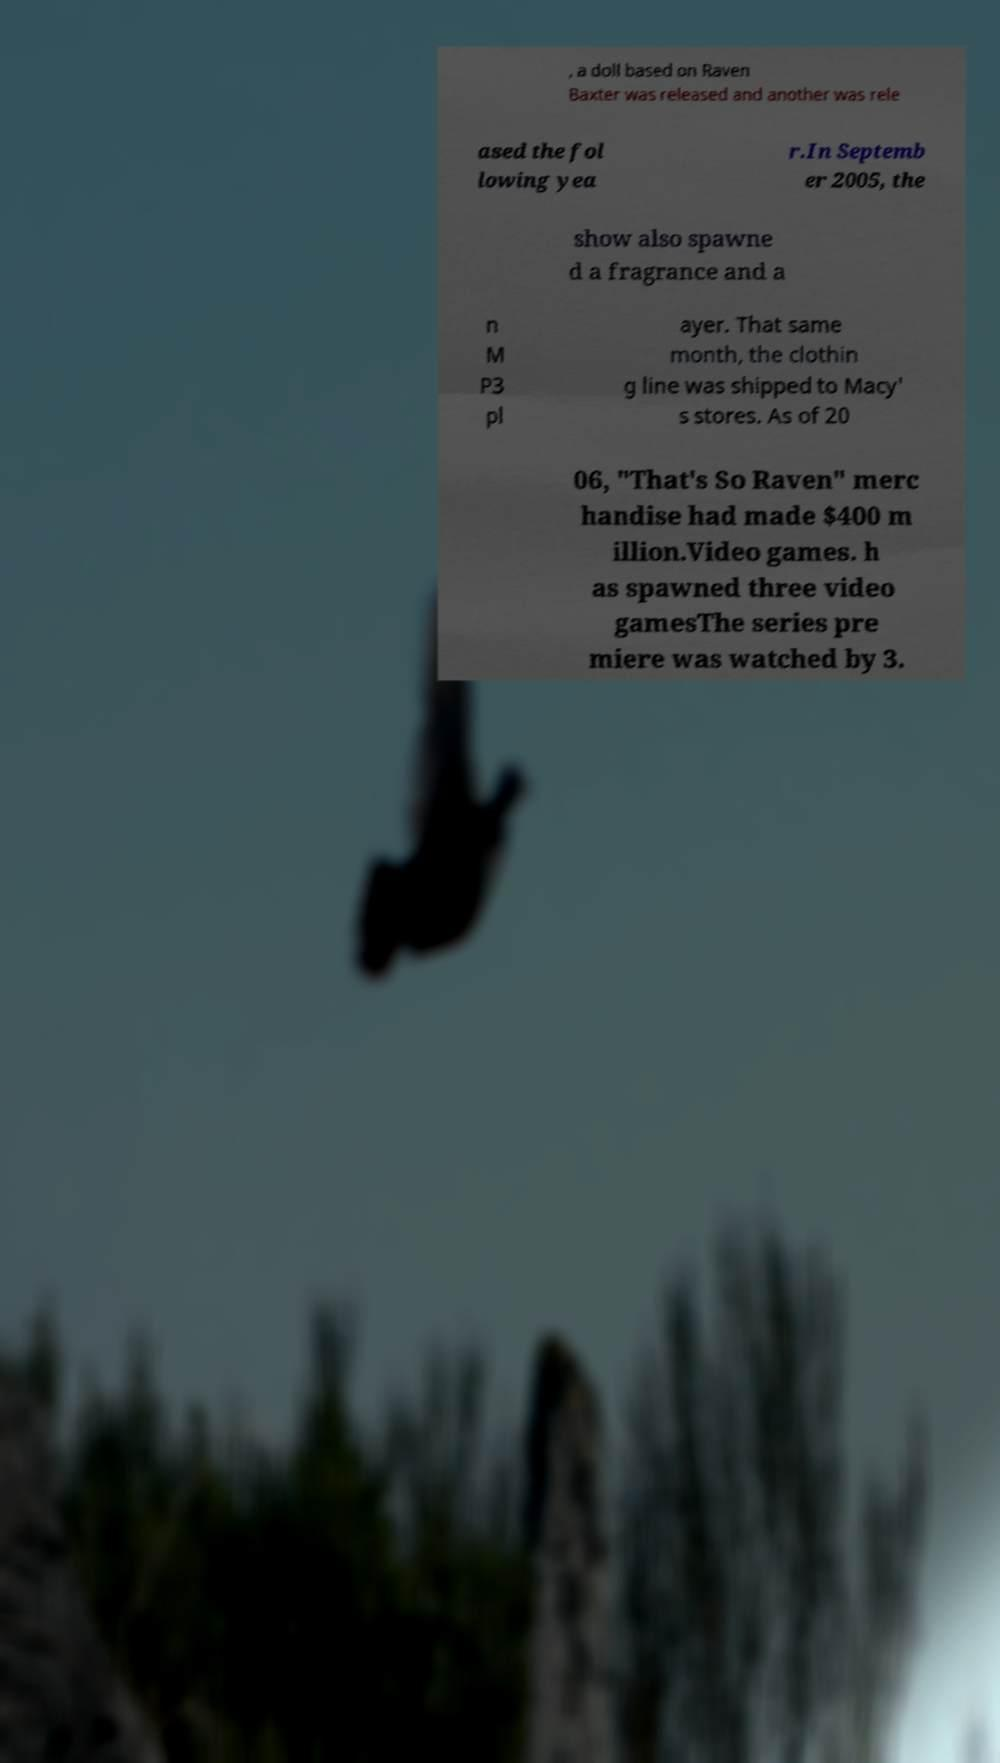Please identify and transcribe the text found in this image. , a doll based on Raven Baxter was released and another was rele ased the fol lowing yea r.In Septemb er 2005, the show also spawne d a fragrance and a n M P3 pl ayer. That same month, the clothin g line was shipped to Macy' s stores. As of 20 06, "That's So Raven" merc handise had made $400 m illion.Video games. h as spawned three video gamesThe series pre miere was watched by 3. 